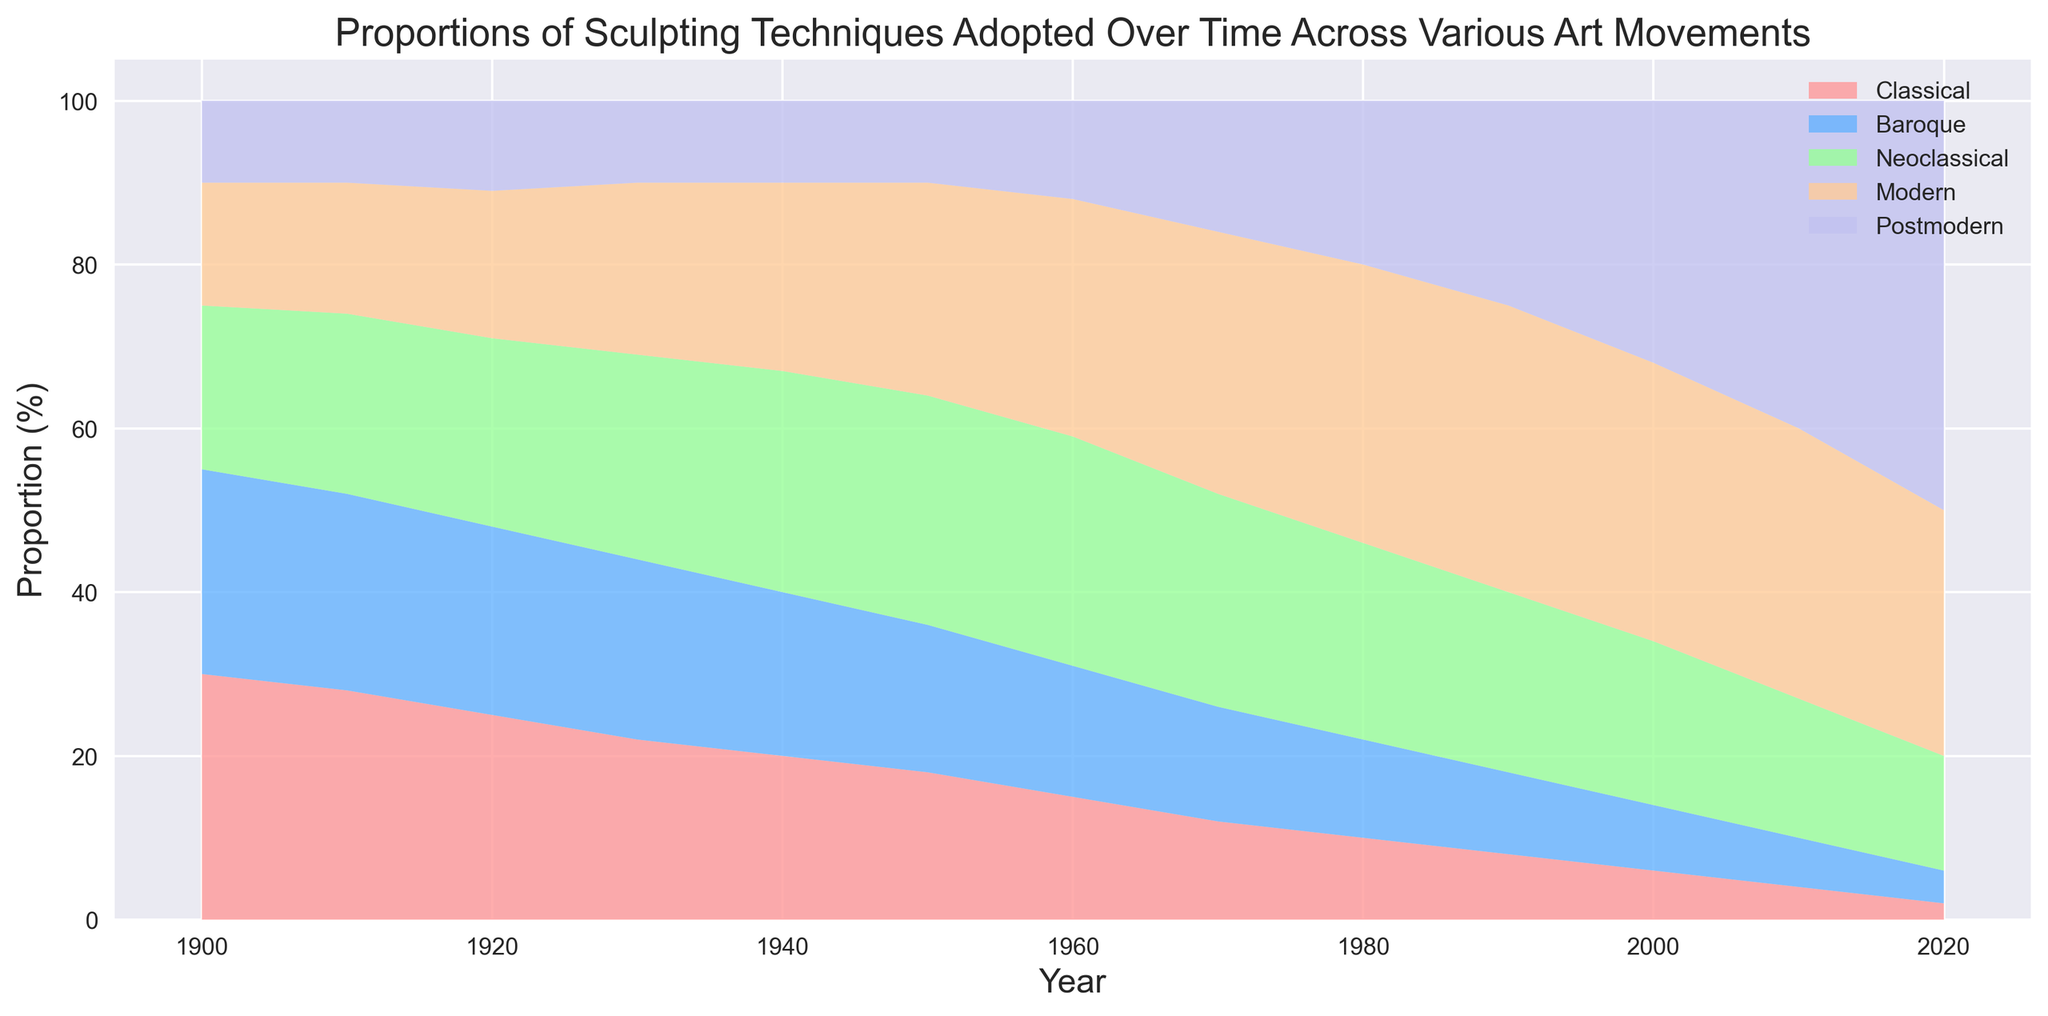Which sculpting technique has consistently decreased in proportion over the years? By examining the trends over the years, the "Classical" technique has consistently shown a decrease in its proportion, starting from 30% in 1900 and gradually falling to 2% in 2020.
Answer: Classical In 1980, which sculpting technique had a higher proportion: Neoclassical or Postmodern? In 1980, the Neoclassical technique had a proportion of 24% while the Postmodern technique had a proportion of 20%. By comparing these percentages, we see that Neoclassical had a higher proportion.
Answer: Neoclassical During which decade did the Modern sculpting technique surpass all other techniques in proportion? Observing the graph, the Modern technique surpasses all other techniques in the proportion during the 1990s, as it reaches its peak and maintains the highest proportion compared to other techniques.
Answer: 1990s What is the total proportion of Classical and Baroque techniques combined in the year 1910? In 1910, the Classical technique is 28% and the Baroque technique is 24%. Adding these together, the combined proportion is 28% + 24% = 52%.
Answer: 52% How does the proportion of Postmodern technique in 2000 compare to its proportion in 2020? In the year 2000, the proportion of the Postmodern technique is 32%. In 2020, it rises to 50%. Comparing these values, the proportion increased by 18 percentage points over the two decades.
Answer: The proportion increased Which sculpting technique shows the smallest change in proportion from 1900 to 2020? By examining the start and end values of all techniques from 1900 to 2020, the Baroque technique changes from 25% to 4%, which is the smallest overall change (a decrease of 21 percentage points).
Answer: Baroque What is the difference in proportion between the highest and lowest techniques in 1960? In 1960, the highest proportion is the Neoclassical technique at 28%, and the lowest is the Postmodern technique at 12%. The difference in their proportions is 28% - 12% = 16%.
Answer: 16% Which technique first exceeded 30% in any given year throughout the timeline provided? The Modern technique is the first to exceed 30% in 1970 when it reached 32%, becoming the first technique in the timeline to surpass this proportion.
Answer: Modern How many techniques have proportions that fall below 10% by the year 2020? In 2020, the Classical technique (2%) and Baroque technique (4%) both fall below 10%, making it two techniques in total.
Answer: 2 techniques 